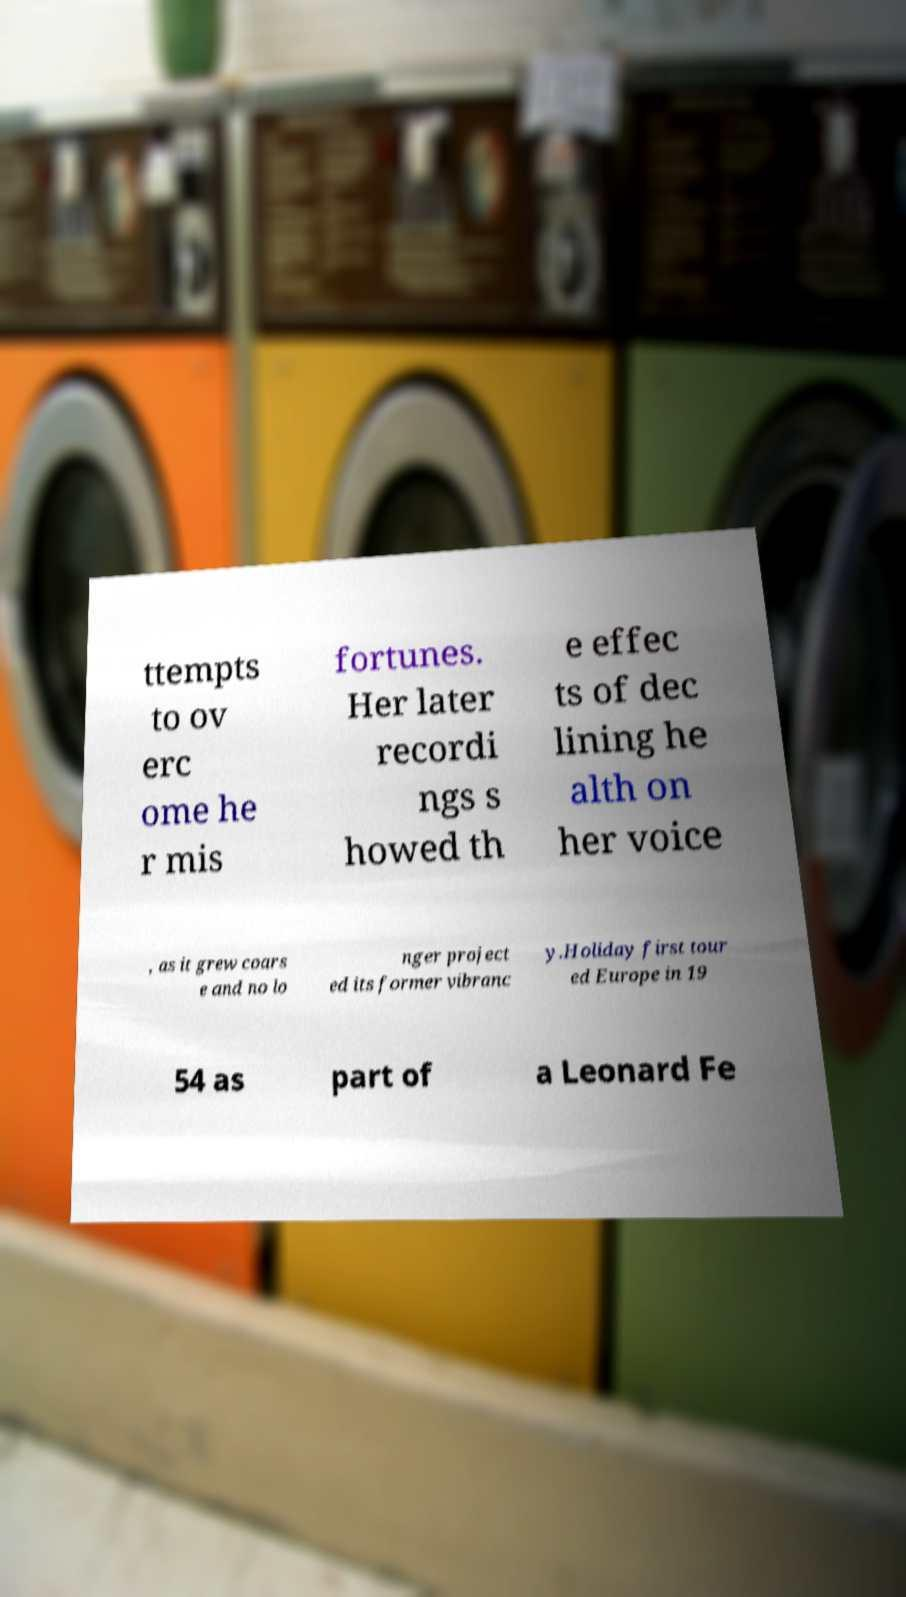I need the written content from this picture converted into text. Can you do that? ttempts to ov erc ome he r mis fortunes. Her later recordi ngs s howed th e effec ts of dec lining he alth on her voice , as it grew coars e and no lo nger project ed its former vibranc y.Holiday first tour ed Europe in 19 54 as part of a Leonard Fe 